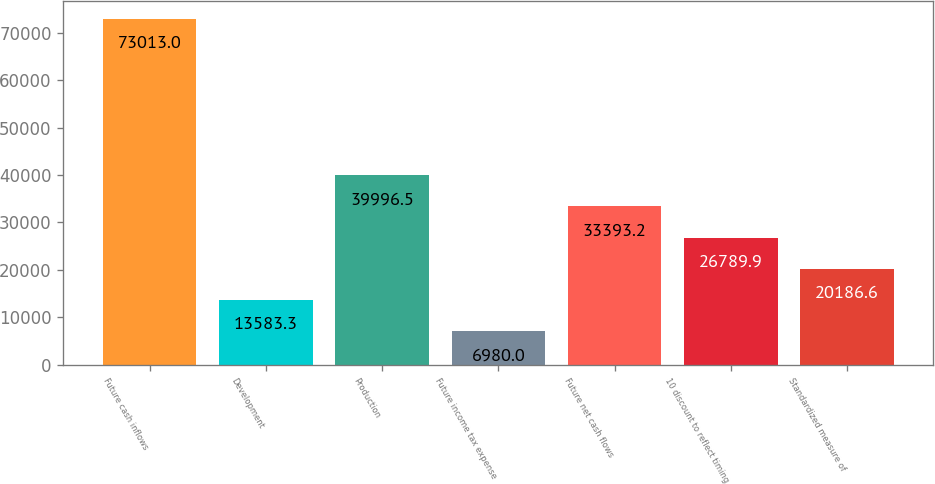Convert chart to OTSL. <chart><loc_0><loc_0><loc_500><loc_500><bar_chart><fcel>Future cash inflows<fcel>Development<fcel>Production<fcel>Future income tax expense<fcel>Future net cash flows<fcel>10 discount to reflect timing<fcel>Standardized measure of<nl><fcel>73013<fcel>13583.3<fcel>39996.5<fcel>6980<fcel>33393.2<fcel>26789.9<fcel>20186.6<nl></chart> 